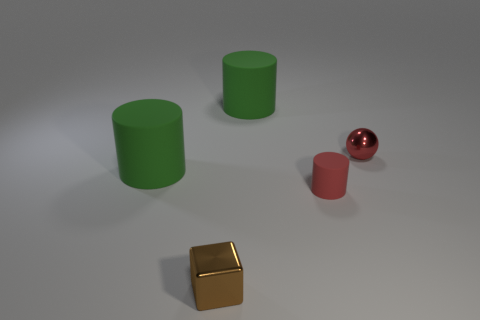Is the number of large green matte cylinders that are behind the small red sphere greater than the number of red things that are in front of the tiny cylinder?
Your response must be concise. Yes. How many other objects are there of the same color as the tiny cube?
Provide a short and direct response. 0. Is the color of the tiny metal ball the same as the tiny rubber object to the right of the tiny brown metallic object?
Offer a very short reply. Yes. How many large green cylinders are to the right of the metal thing behind the small rubber cylinder?
Your answer should be compact. 0. There is a small object behind the large cylinder on the left side of the tiny shiny thing that is to the left of the small red rubber object; what is its material?
Your response must be concise. Metal. What number of other small brown shiny objects have the same shape as the brown thing?
Provide a short and direct response. 0. There is a matte object behind the object right of the tiny cylinder; how big is it?
Your answer should be compact. Large. There is a big object that is in front of the red shiny thing; does it have the same color as the large matte object that is right of the brown metal object?
Keep it short and to the point. Yes. How many green rubber things are in front of the large thing to the left of the matte thing that is behind the small shiny ball?
Offer a terse response. 0. What number of objects are both behind the red shiny sphere and in front of the tiny red matte object?
Your response must be concise. 0. 